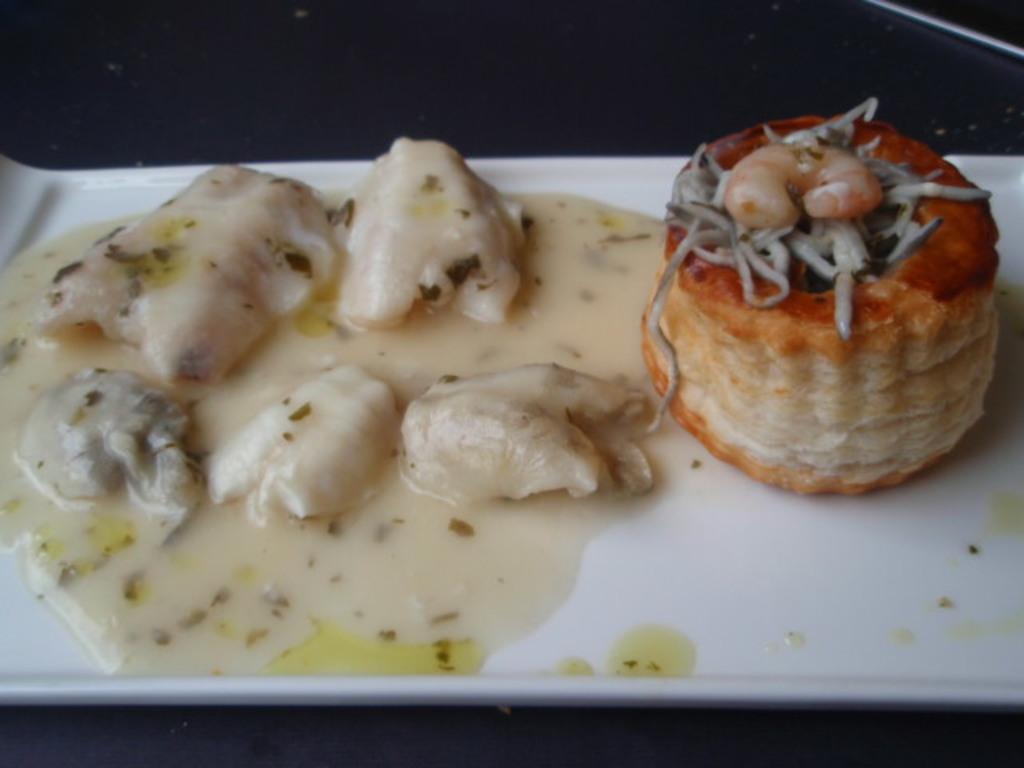In one or two sentences, can you explain what this image depicts? In the image we can see there are food items kept on the white colour plate. 